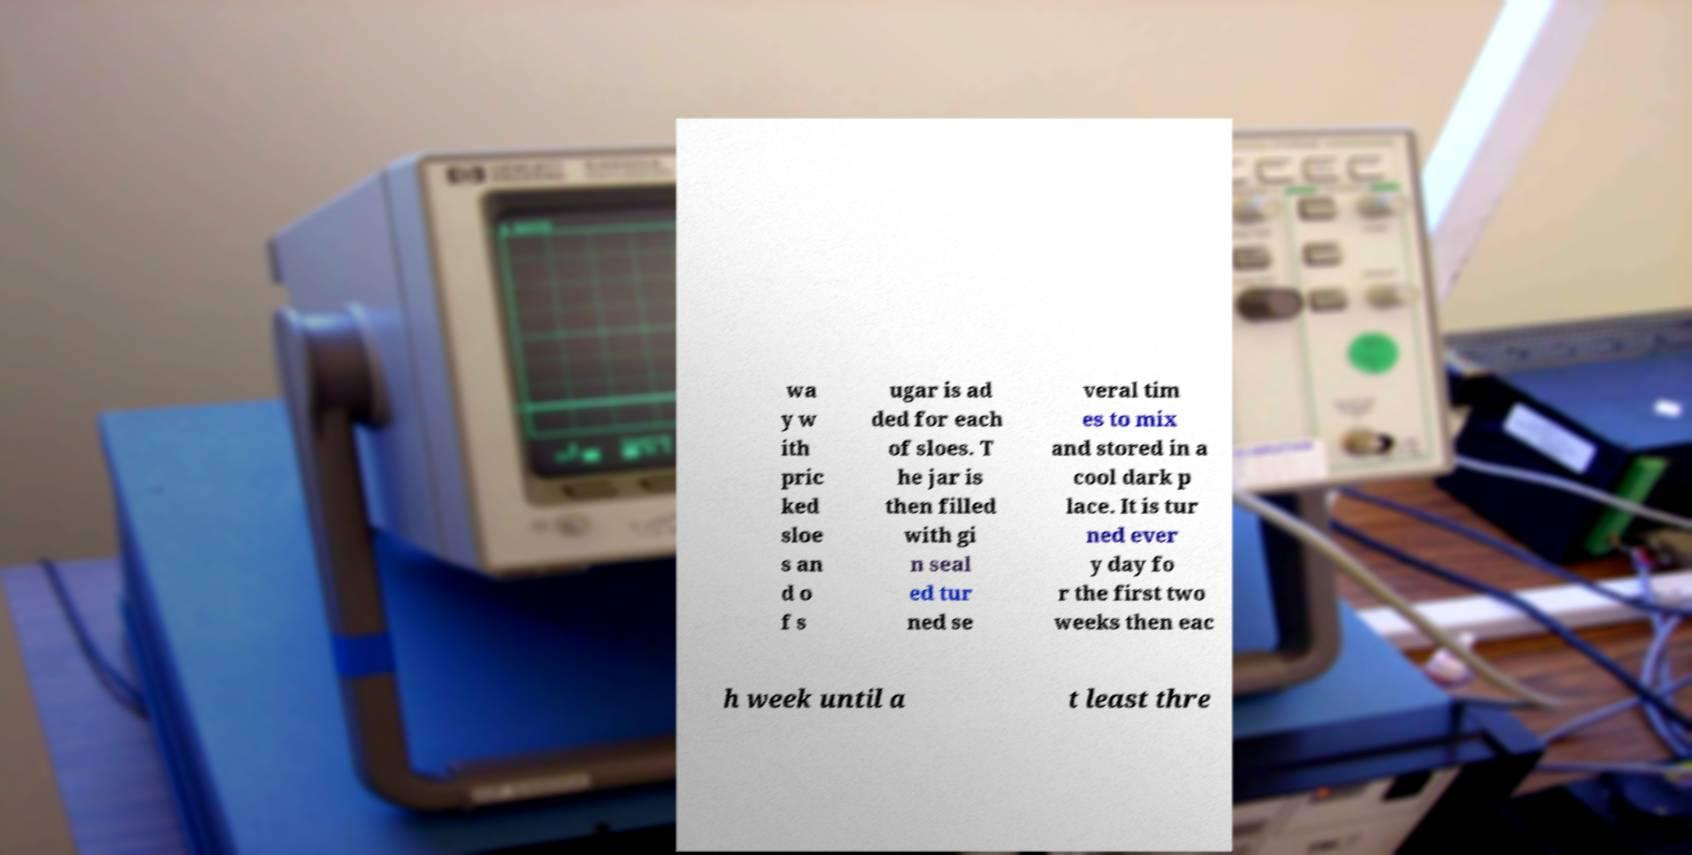Can you accurately transcribe the text from the provided image for me? wa y w ith pric ked sloe s an d o f s ugar is ad ded for each of sloes. T he jar is then filled with gi n seal ed tur ned se veral tim es to mix and stored in a cool dark p lace. It is tur ned ever y day fo r the first two weeks then eac h week until a t least thre 